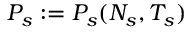Convert formula to latex. <formula><loc_0><loc_0><loc_500><loc_500>P _ { s } \colon = P _ { s } ( N _ { s } , T _ { s } )</formula> 